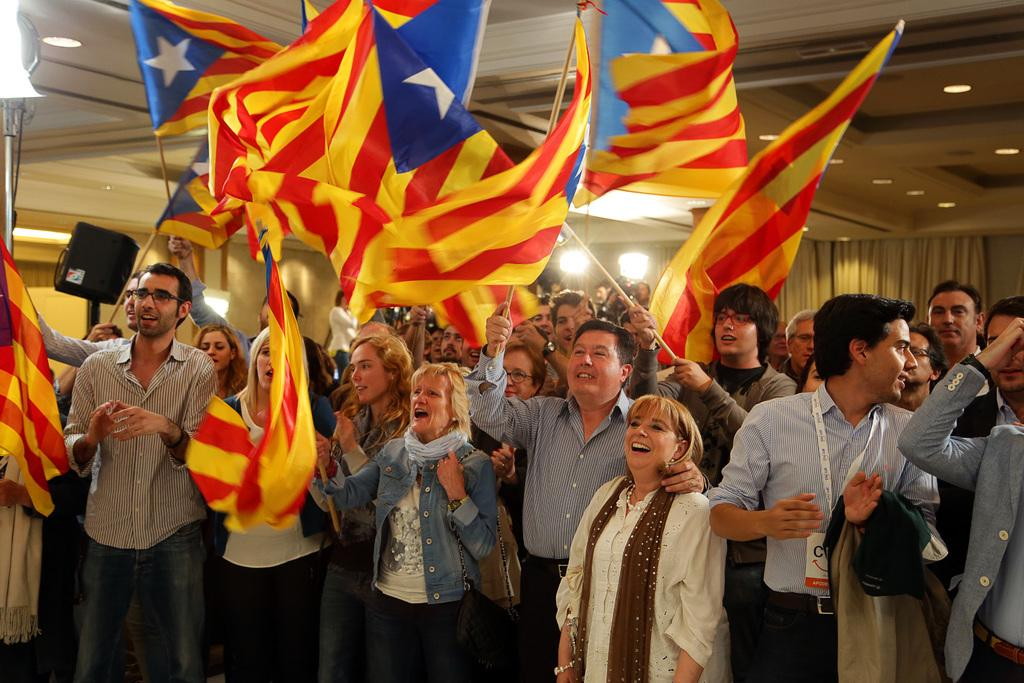What is happening in the image involving a group of people? The people in the image are holding flags. What colors can be seen on the flags? The flags have blue, white, yellow, and red colors. What can be seen in the background of the image? There are lights visible in the background of the image. What type of wax is being used by the sister in the image? There is no sister or wax present in the image. What station is the group of people waiting at in the image? There is no indication of a station or any transportation-related context in the image. 